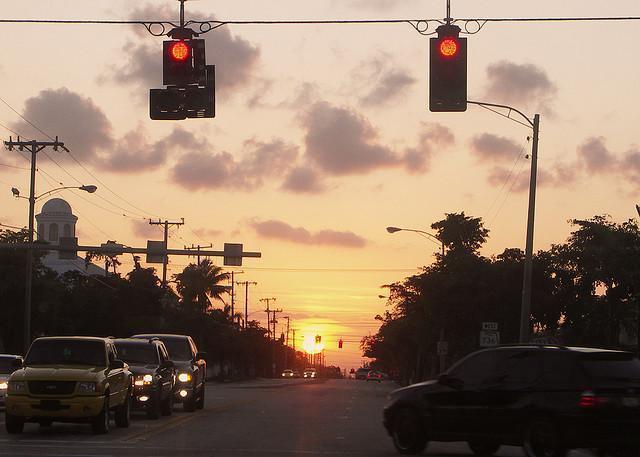How many cars can be seen?
Give a very brief answer. 4. 